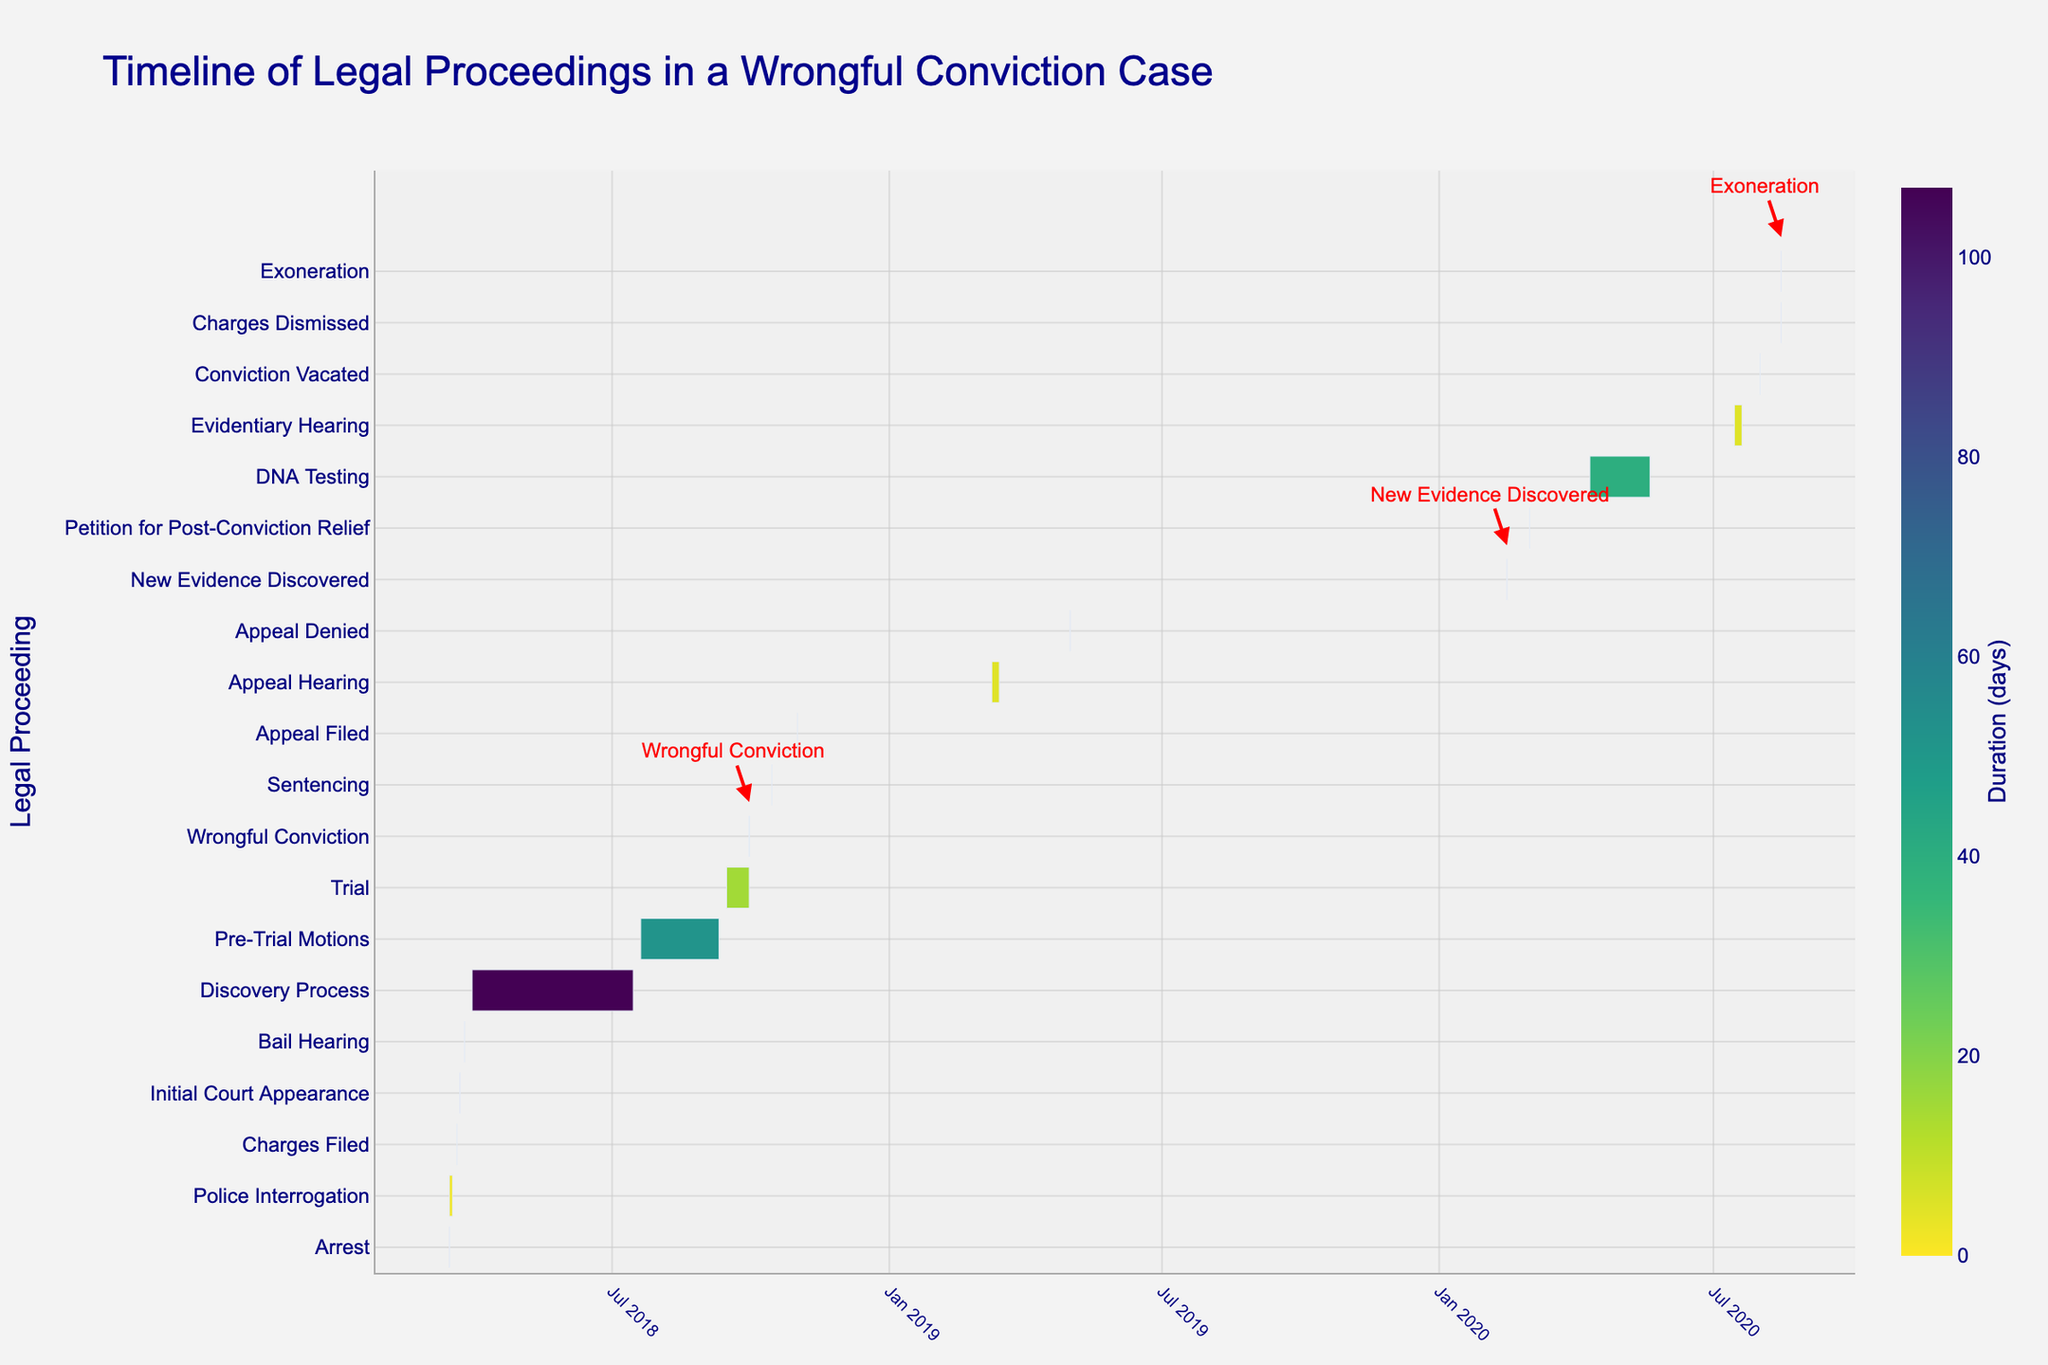**Basic Question 1:**
What is the title of the figure? The title of a figure is usually prominently displayed at the top of the chart. In this case, the title can be found at the top of the Gantt chart.
Answer: Timeline of Legal Proceedings in a Wrongful Conviction Case **Basic Question 2:**
What is the color of the bars in the Gantt chart? The color of the bars can be determined by visually inspecting the bars within the Gantt chart. The bars show a sequential color scheme which varies in shade.
Answer: Sequential shades of Viridis **Compositional Question 1:**
How many days did the Discovery Process take? To find the duration of the Discovery Process, subtract the start date (2018-03-30) from the end date (2018-07-15). This involves calculating the difference between these two dates.
Answer: 107 days **Compositional Question 2:**
How many days passed between the Wrongful Conviction and the Exoneration? Calculate the duration between the two events by subtracting the date of the wrongful conviction (2018-09-30) from the date of exoneration (2020-08-15). This involves counting the total days between these two dates.
Answer: 685 days **Comparison Question 1:**
Which lasted longer: the Discovery Process or the DNA Testing? Compare the duration of the Discovery Process (107 days) with the duration of DNA Testing (40 days).
Answer: Discovery Process **Comparison Question 2:**
Which event took place closest to the Appeal Denied event? Identify the event dates close to the Appeal Denied event (2019-05-01) on both ends of the timeline. Then, calculate the duration from the Appeal Denied event to those events to determine the closest one.
Answer: Appeal Hearing **Chart-Type Specific Question 1:**
Which event is marked by a red arrow in the figure? Look for the annotations with red arrows pointing to specific events within the Gantt chart. These are highlighted for key events.
Answer: Wrongful Conviction, New Evidence Discovered, Exoneration **Chart-Type Specific Question 2:**
During which year did the most legal proceedings occur? Count the number of events that fall within each year as depicted in the Gantt chart and identify the year with the highest count.
Answer: 2018 